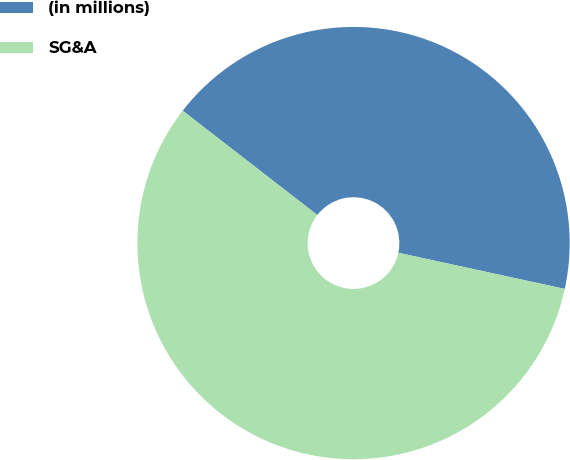<chart> <loc_0><loc_0><loc_500><loc_500><pie_chart><fcel>(in millions)<fcel>SG&A<nl><fcel>42.91%<fcel>57.09%<nl></chart> 